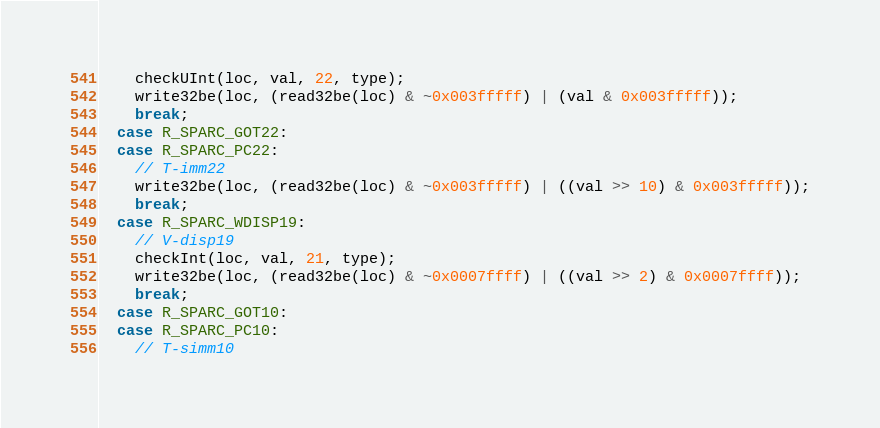<code> <loc_0><loc_0><loc_500><loc_500><_C++_>    checkUInt(loc, val, 22, type);
    write32be(loc, (read32be(loc) & ~0x003fffff) | (val & 0x003fffff));
    break;
  case R_SPARC_GOT22:
  case R_SPARC_PC22:
    // T-imm22
    write32be(loc, (read32be(loc) & ~0x003fffff) | ((val >> 10) & 0x003fffff));
    break;
  case R_SPARC_WDISP19:
    // V-disp19
    checkInt(loc, val, 21, type);
    write32be(loc, (read32be(loc) & ~0x0007ffff) | ((val >> 2) & 0x0007ffff));
    break;
  case R_SPARC_GOT10:
  case R_SPARC_PC10:
    // T-simm10</code> 